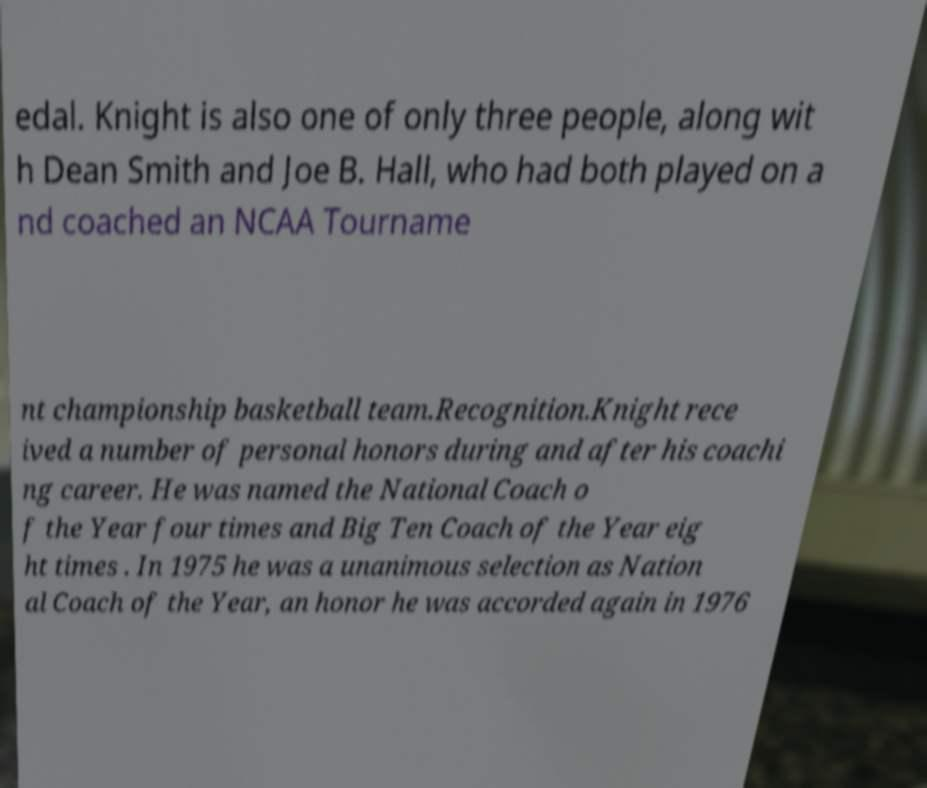There's text embedded in this image that I need extracted. Can you transcribe it verbatim? edal. Knight is also one of only three people, along wit h Dean Smith and Joe B. Hall, who had both played on a nd coached an NCAA Tourname nt championship basketball team.Recognition.Knight rece ived a number of personal honors during and after his coachi ng career. He was named the National Coach o f the Year four times and Big Ten Coach of the Year eig ht times . In 1975 he was a unanimous selection as Nation al Coach of the Year, an honor he was accorded again in 1976 